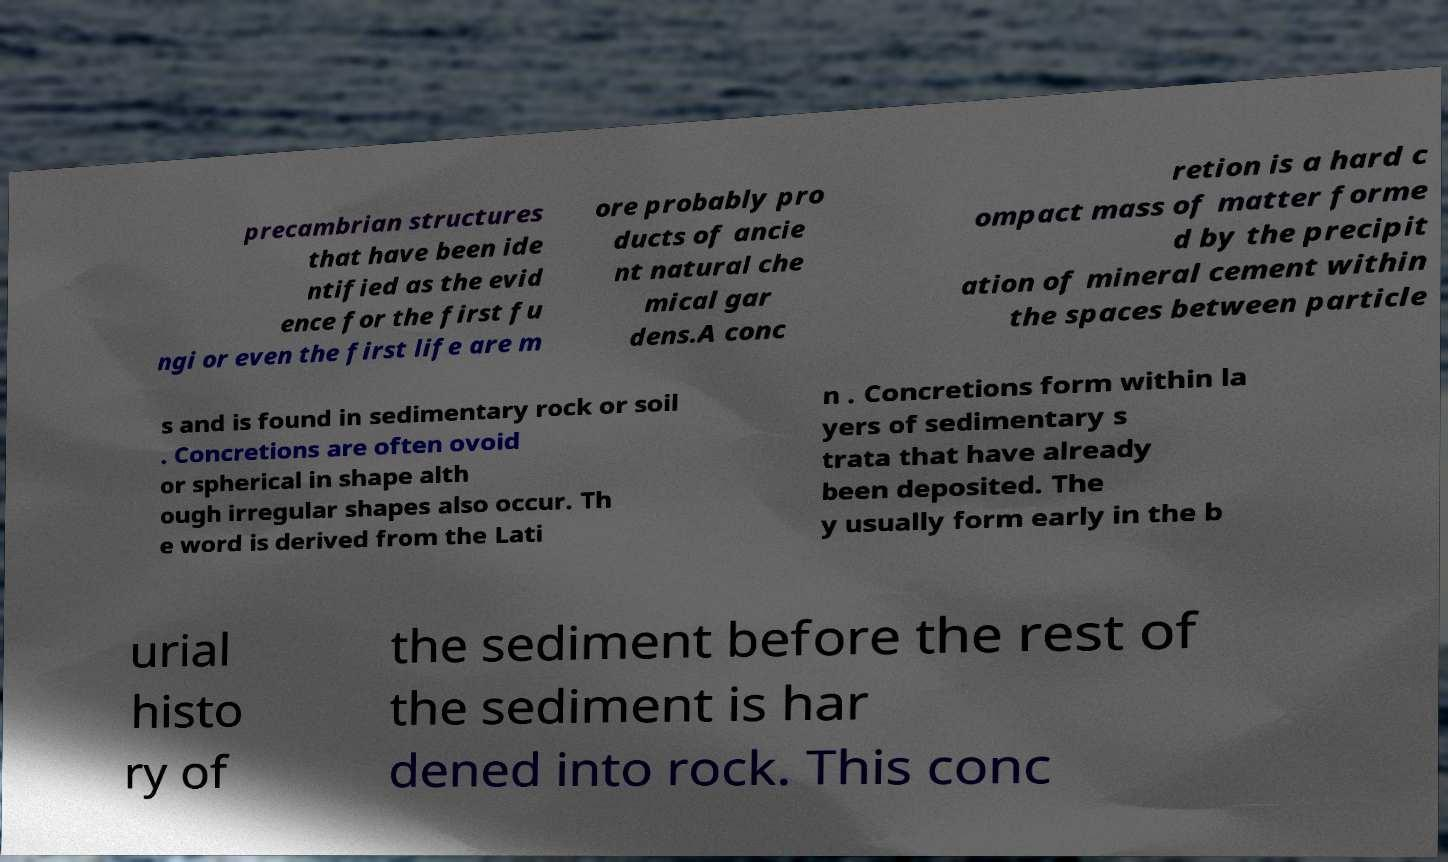There's text embedded in this image that I need extracted. Can you transcribe it verbatim? precambrian structures that have been ide ntified as the evid ence for the first fu ngi or even the first life are m ore probably pro ducts of ancie nt natural che mical gar dens.A conc retion is a hard c ompact mass of matter forme d by the precipit ation of mineral cement within the spaces between particle s and is found in sedimentary rock or soil . Concretions are often ovoid or spherical in shape alth ough irregular shapes also occur. Th e word is derived from the Lati n . Concretions form within la yers of sedimentary s trata that have already been deposited. The y usually form early in the b urial histo ry of the sediment before the rest of the sediment is har dened into rock. This conc 